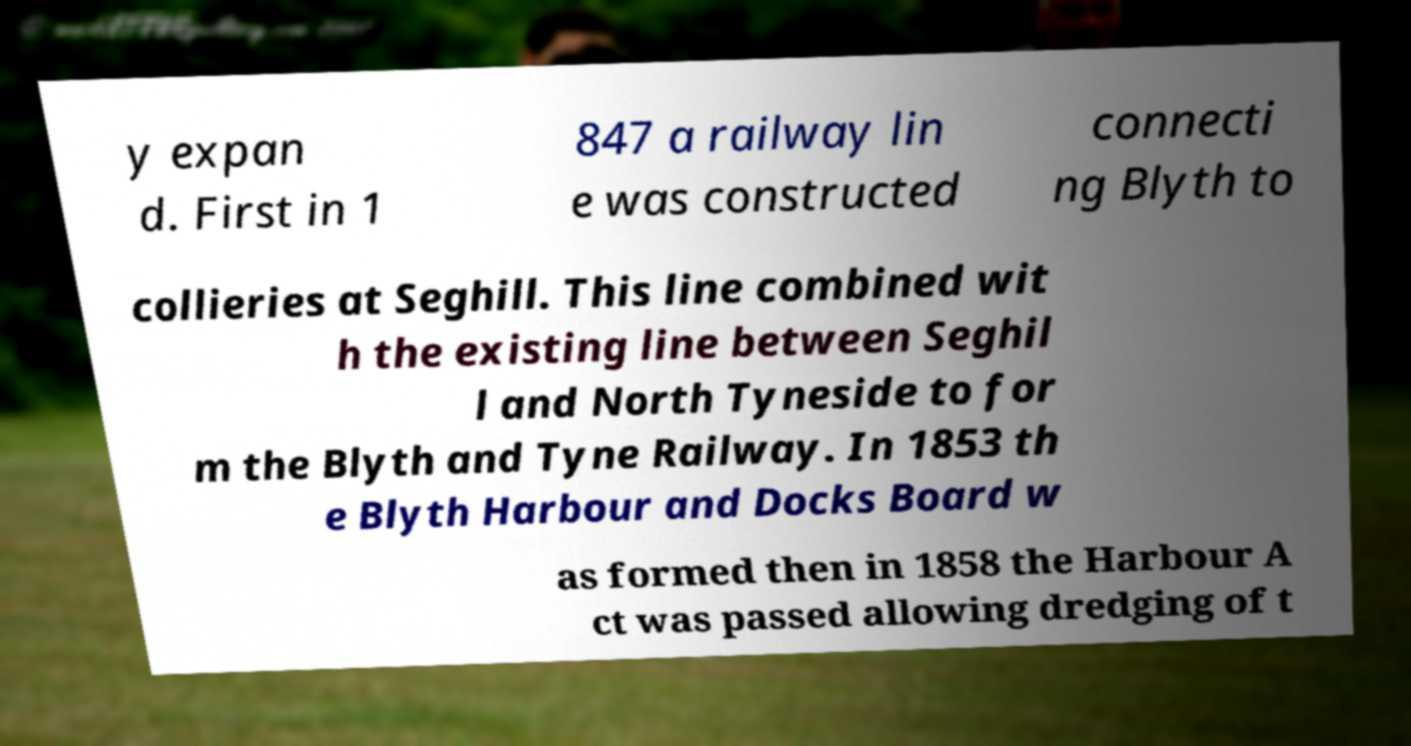What messages or text are displayed in this image? I need them in a readable, typed format. y expan d. First in 1 847 a railway lin e was constructed connecti ng Blyth to collieries at Seghill. This line combined wit h the existing line between Seghil l and North Tyneside to for m the Blyth and Tyne Railway. In 1853 th e Blyth Harbour and Docks Board w as formed then in 1858 the Harbour A ct was passed allowing dredging of t 